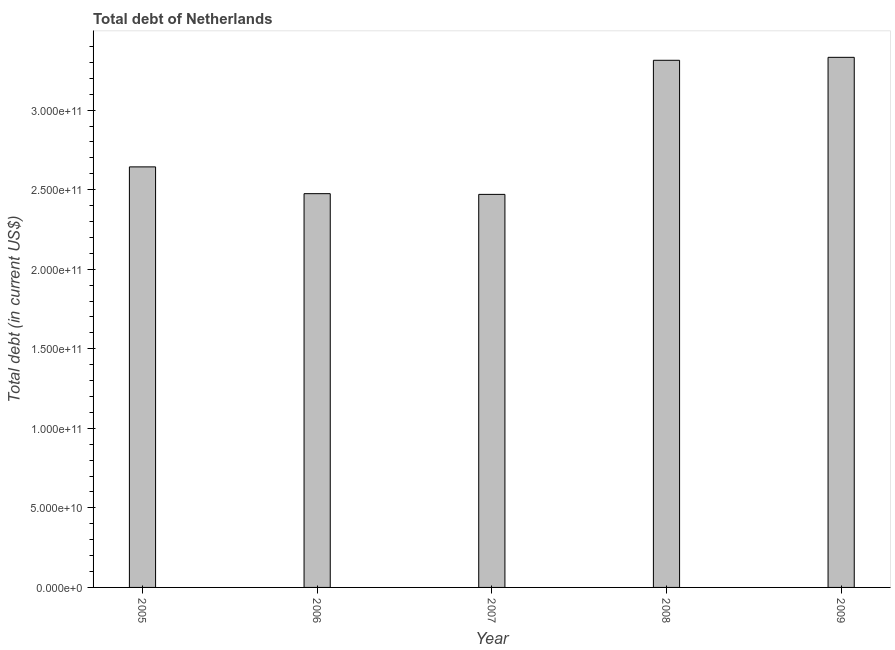Does the graph contain grids?
Ensure brevity in your answer.  No. What is the title of the graph?
Make the answer very short. Total debt of Netherlands. What is the label or title of the Y-axis?
Offer a very short reply. Total debt (in current US$). What is the total debt in 2005?
Offer a terse response. 2.64e+11. Across all years, what is the maximum total debt?
Your response must be concise. 3.33e+11. Across all years, what is the minimum total debt?
Provide a short and direct response. 2.47e+11. In which year was the total debt maximum?
Your answer should be very brief. 2009. In which year was the total debt minimum?
Your answer should be very brief. 2007. What is the sum of the total debt?
Offer a very short reply. 1.42e+12. What is the difference between the total debt in 2006 and 2007?
Provide a succinct answer. 4.52e+08. What is the average total debt per year?
Your response must be concise. 2.85e+11. What is the median total debt?
Offer a terse response. 2.64e+11. What is the ratio of the total debt in 2006 to that in 2008?
Ensure brevity in your answer.  0.75. Is the total debt in 2005 less than that in 2007?
Give a very brief answer. No. What is the difference between the highest and the second highest total debt?
Make the answer very short. 1.86e+09. Is the sum of the total debt in 2006 and 2008 greater than the maximum total debt across all years?
Keep it short and to the point. Yes. What is the difference between the highest and the lowest total debt?
Ensure brevity in your answer.  8.61e+1. In how many years, is the total debt greater than the average total debt taken over all years?
Your answer should be very brief. 2. Are all the bars in the graph horizontal?
Your answer should be very brief. No. How many years are there in the graph?
Your answer should be compact. 5. What is the difference between two consecutive major ticks on the Y-axis?
Offer a terse response. 5.00e+1. Are the values on the major ticks of Y-axis written in scientific E-notation?
Keep it short and to the point. Yes. What is the Total debt (in current US$) of 2005?
Offer a terse response. 2.64e+11. What is the Total debt (in current US$) of 2006?
Provide a succinct answer. 2.47e+11. What is the Total debt (in current US$) in 2007?
Provide a short and direct response. 2.47e+11. What is the Total debt (in current US$) of 2008?
Make the answer very short. 3.31e+11. What is the Total debt (in current US$) of 2009?
Make the answer very short. 3.33e+11. What is the difference between the Total debt (in current US$) in 2005 and 2006?
Provide a short and direct response. 1.68e+1. What is the difference between the Total debt (in current US$) in 2005 and 2007?
Provide a short and direct response. 1.73e+1. What is the difference between the Total debt (in current US$) in 2005 and 2008?
Offer a terse response. -6.70e+1. What is the difference between the Total debt (in current US$) in 2005 and 2009?
Provide a succinct answer. -6.89e+1. What is the difference between the Total debt (in current US$) in 2006 and 2007?
Your answer should be very brief. 4.52e+08. What is the difference between the Total debt (in current US$) in 2006 and 2008?
Offer a terse response. -8.38e+1. What is the difference between the Total debt (in current US$) in 2006 and 2009?
Provide a succinct answer. -8.57e+1. What is the difference between the Total debt (in current US$) in 2007 and 2008?
Provide a short and direct response. -8.43e+1. What is the difference between the Total debt (in current US$) in 2007 and 2009?
Provide a short and direct response. -8.61e+1. What is the difference between the Total debt (in current US$) in 2008 and 2009?
Ensure brevity in your answer.  -1.86e+09. What is the ratio of the Total debt (in current US$) in 2005 to that in 2006?
Provide a short and direct response. 1.07. What is the ratio of the Total debt (in current US$) in 2005 to that in 2007?
Your answer should be very brief. 1.07. What is the ratio of the Total debt (in current US$) in 2005 to that in 2008?
Your response must be concise. 0.8. What is the ratio of the Total debt (in current US$) in 2005 to that in 2009?
Keep it short and to the point. 0.79. What is the ratio of the Total debt (in current US$) in 2006 to that in 2008?
Your answer should be very brief. 0.75. What is the ratio of the Total debt (in current US$) in 2006 to that in 2009?
Your answer should be compact. 0.74. What is the ratio of the Total debt (in current US$) in 2007 to that in 2008?
Offer a very short reply. 0.75. What is the ratio of the Total debt (in current US$) in 2007 to that in 2009?
Ensure brevity in your answer.  0.74. 